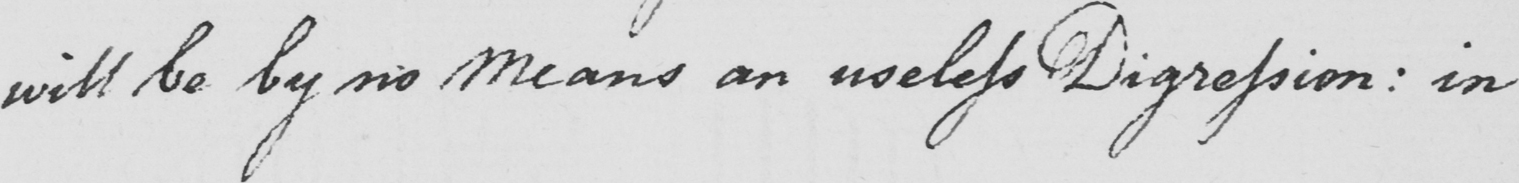Please provide the text content of this handwritten line. will be by no Means an useless Digression :  in 